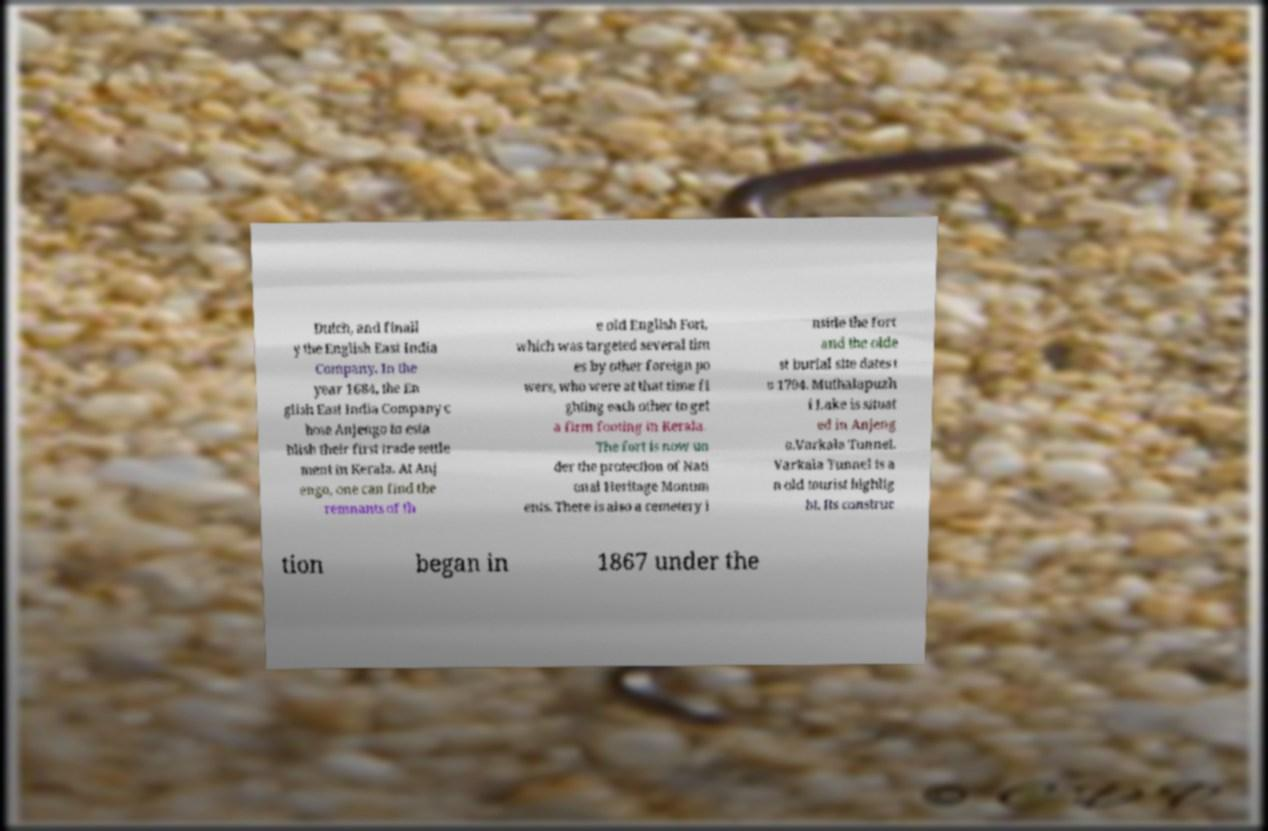Can you accurately transcribe the text from the provided image for me? Dutch, and finall y the English East India Company. In the year 1684, the En glish East India Company c hose Anjengo to esta blish their first trade settle ment in Kerala. At Anj engo, one can find the remnants of th e old English Fort, which was targeted several tim es by other foreign po wers, who were at that time fi ghting each other to get a firm footing in Kerala. The fort is now un der the protection of Nati onal Heritage Monum ents. There is also a cemetery i nside the fort and the olde st burial site dates t o 1704. Muthalapuzh i Lake is situat ed in Anjeng o.Varkala Tunnel. Varkala Tunnel is a n old tourist highlig ht. Its construc tion began in 1867 under the 